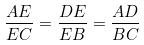<formula> <loc_0><loc_0><loc_500><loc_500>\frac { A E } { E C } = \frac { D E } { E B } = \frac { A D } { B C }</formula> 